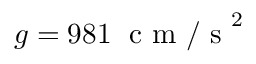<formula> <loc_0><loc_0><loc_500><loc_500>g = 9 8 1 \, c m / s ^ { 2 }</formula> 